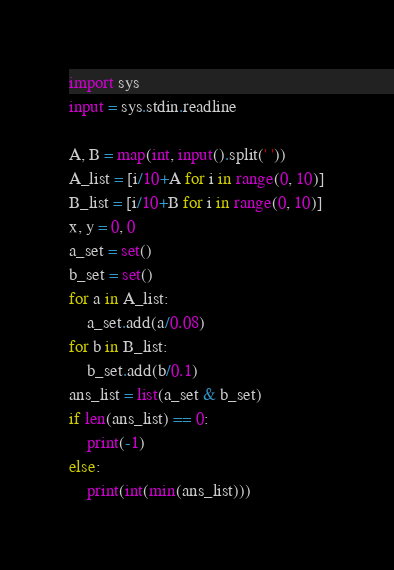<code> <loc_0><loc_0><loc_500><loc_500><_Python_>import sys
input = sys.stdin.readline

A, B = map(int, input().split(' '))
A_list = [i/10+A for i in range(0, 10)]
B_list = [i/10+B for i in range(0, 10)]
x, y = 0, 0
a_set = set()
b_set = set()
for a in A_list:
    a_set.add(a/0.08)
for b in B_list:
    b_set.add(b/0.1)
ans_list = list(a_set & b_set)
if len(ans_list) == 0:
    print(-1)
else:
    print(int(min(ans_list)))</code> 